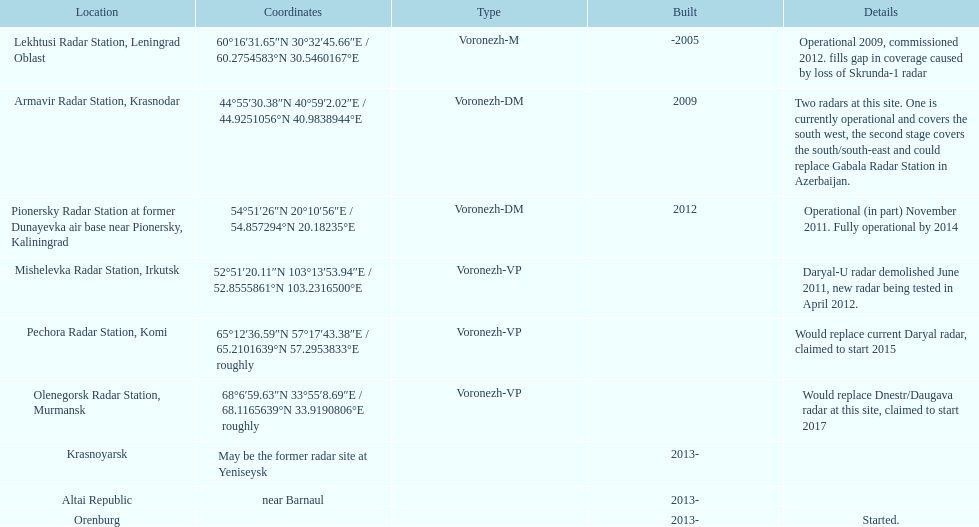How many voronezh radars were established before 2010? 2. 